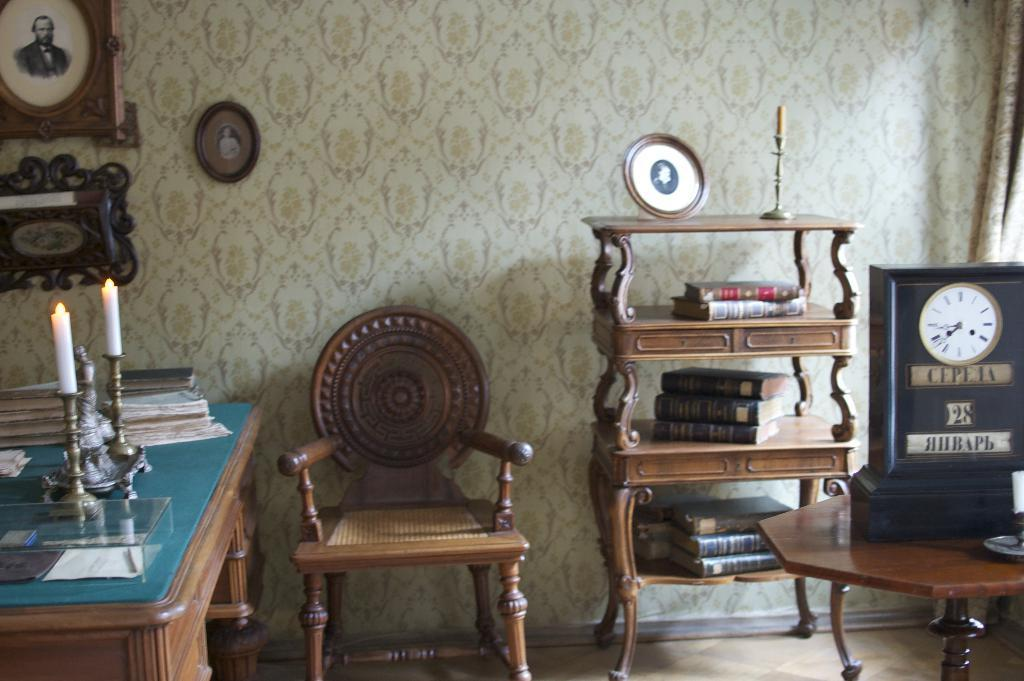What objects are present in the image that are used for displaying photos? There are photo frames in the image. What type of furniture is visible in the image? There is a chair and a table in the image. What items can be found on the table? There are books and candles on the table. Where is the book located on the right side of the image? There is a book on the right side of the image. What is the purpose of the rack on the right side of the image? The rack on the right side of the image is likely used for storage or displaying items. What type of arithmetic problem can be solved using the nail on the table in the image? There is no nail present in the image, and therefore no arithmetic problem can be solved using it. How many giants are visible in the image? There are no giants present in the image. 